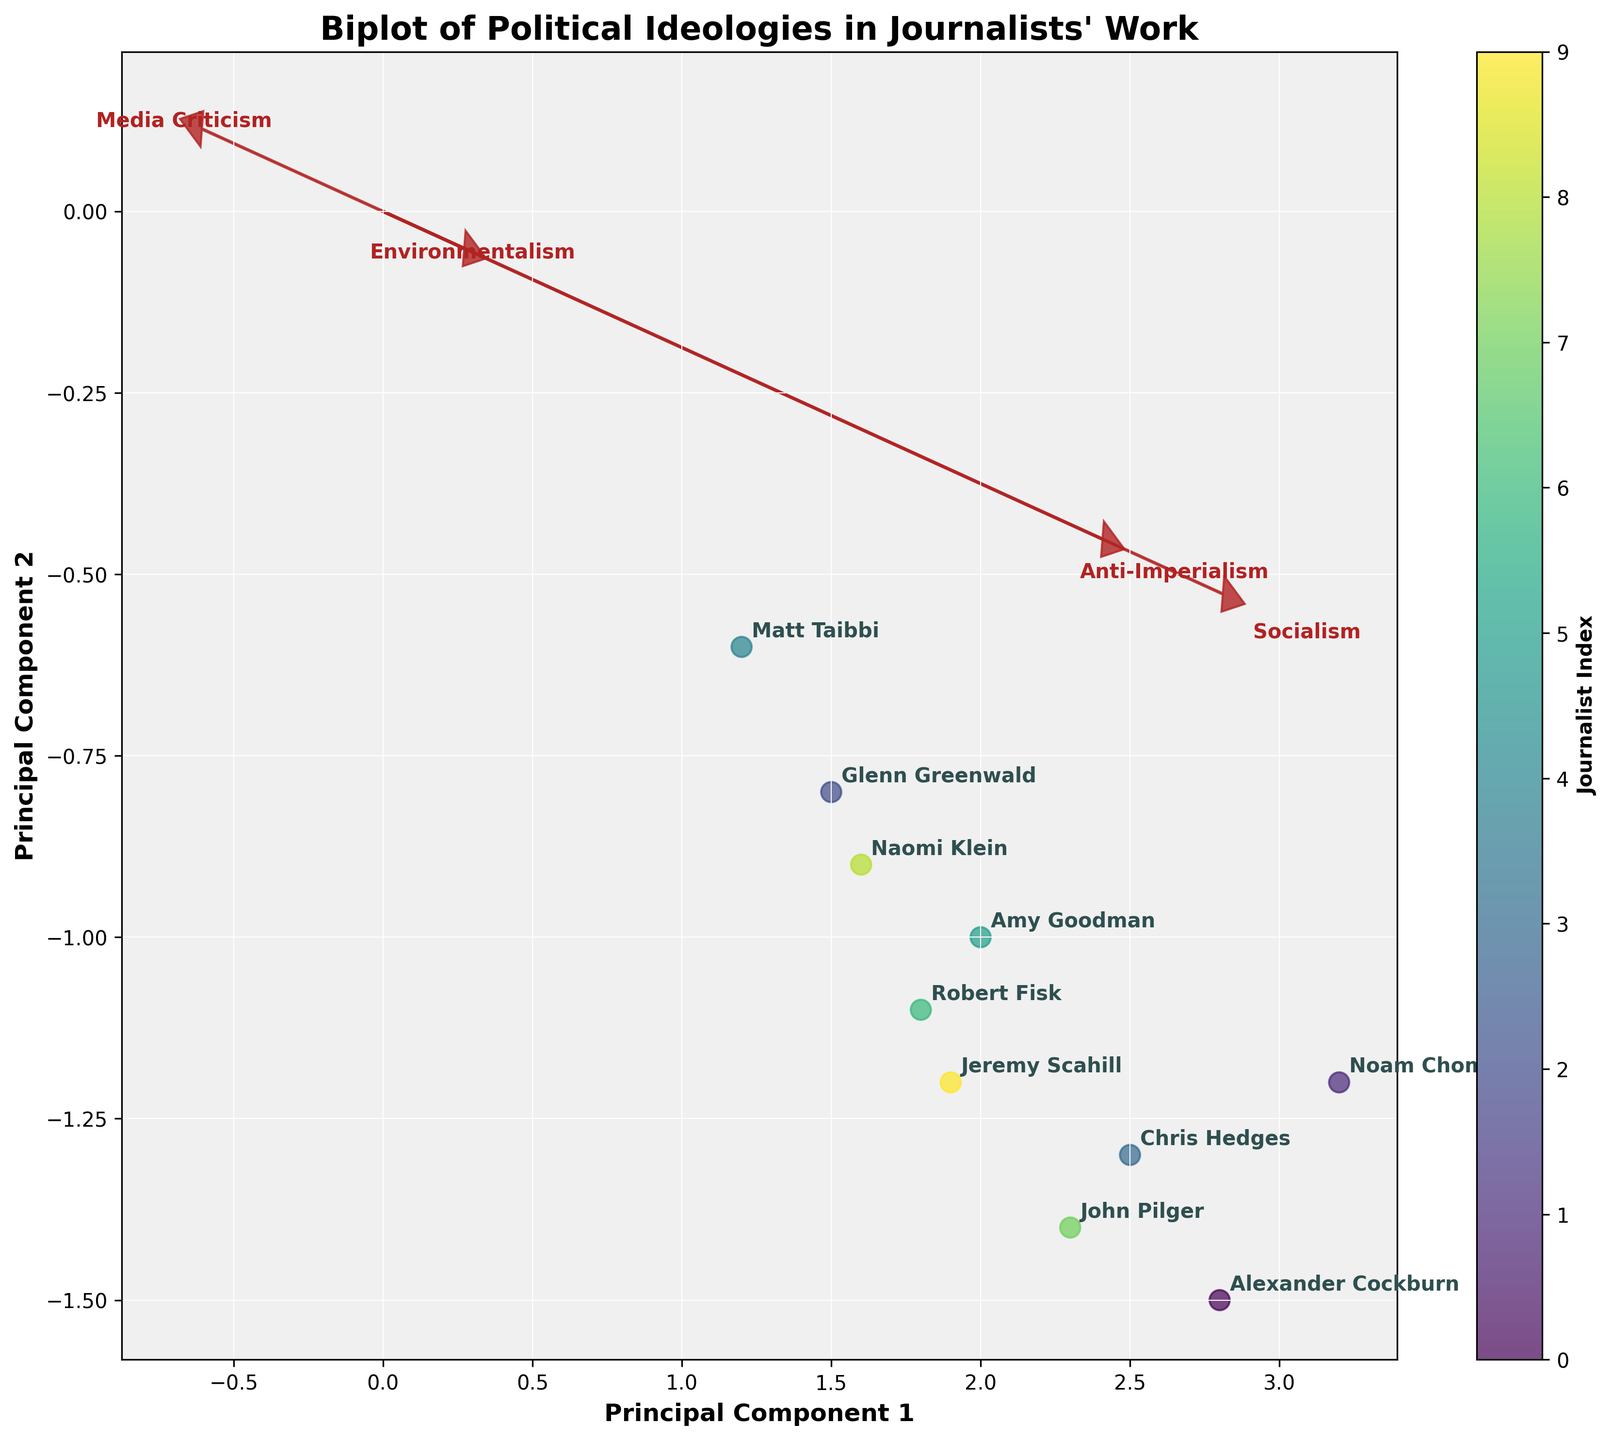What are the labels for the axes on the biplot? The axes are labeled with the names of the principal components. The x-axis is labeled "Principal Component 1" and the y-axis is labeled "Principal Component 2."
Answer: Principal Component 1 and Principal Component 2 How many journalists are plotted in this biplot? You can count the number of unique labels on the plot. There are 10 journalists represented by the labels.
Answer: 10 Which journalist is positioned highest on Principal Component 1? By observing the horizontal positions of the labels on Principal Component 1 (x-axis), Noam Chomsky is farthest to the right.
Answer: Noam Chomsky Which journalist has the lowest PC2 value? By checking the vertical position of the labels on Principal Component 2 (y-axis), Alexander Cockburn is the lowest.
Answer: Alexander Cockburn Which variable has the largest eigenvector along the X-axis? By observing the arrows (eigenvectors) starting from the origin, "Socialism" has the largest projection along the x-axis.
Answer: Socialism What is the relative position of Naomi Klein and Glenn Greenwald in terms of Principal Component 1? Comparing their positions horizontally on the x-axis, Glenn Greenwald is to the left of Naomi Klein, indicating a lower Principal Component 1 value.
Answer: Naomi Klein > Glenn Greenwald Which variable has the smallest contribution to the journalists’ positions along Principal Component 2? Based on the vertical length and direction of the arrows, "Environmentalism" seems to have the smallest contribution to Principal Component 2 as its arrow is shortest in the y-axis direction.
Answer: Environmentalism Are there any journalists who have similar positions in the PC1-PC2 space? If yes, who are they? By observing the clustering of the points, Amy Goodman and Robert Fisk have similar positions close to each other on the biplot.
Answer: Amy Goodman and Robert Fisk Do most journalists align positively or negatively with "Media Criticism"? Since the "Media Criticism" arrow points to the left (negative x-axis direction), and most journalists are on the positive side of the x-axis, most journalists align negatively with "Media Criticism."
Answer: Negatively Which variable is closest to "Anti-Imperialism" in terms of its eigenvector direction? By comparing the directions of the arrows, "Media Criticism" has an arrow direction most similar to "Anti-Imperialism".
Answer: Media Criticism 